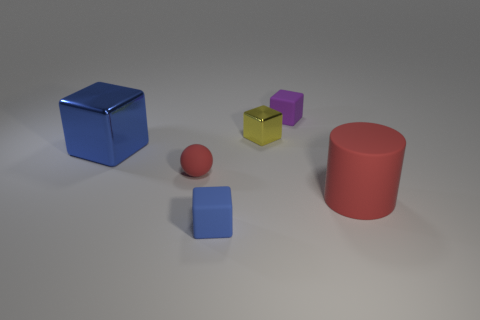What is the material of the block in front of the large object that is left of the matte object that is behind the small matte sphere?
Your answer should be very brief. Rubber. Do the small blue thing and the purple rubber thing have the same shape?
Ensure brevity in your answer.  Yes. What number of objects are both behind the blue matte cube and in front of the tiny purple rubber block?
Give a very brief answer. 4. There is a metallic cube on the right side of the big object left of the big matte thing; what is its color?
Offer a very short reply. Yellow. Is the number of purple cubes that are in front of the small blue cube the same as the number of tiny green shiny objects?
Your answer should be very brief. Yes. There is a tiny matte block on the left side of the purple matte thing that is behind the sphere; what number of matte blocks are behind it?
Offer a terse response. 1. There is a small thing that is right of the tiny yellow metal thing; what is its color?
Offer a very short reply. Purple. What is the object that is in front of the red rubber ball and on the right side of the blue rubber thing made of?
Provide a succinct answer. Rubber. There is a shiny block left of the small blue matte thing; what number of small purple cubes are left of it?
Offer a terse response. 0. What is the shape of the small purple thing?
Provide a succinct answer. Cube. 